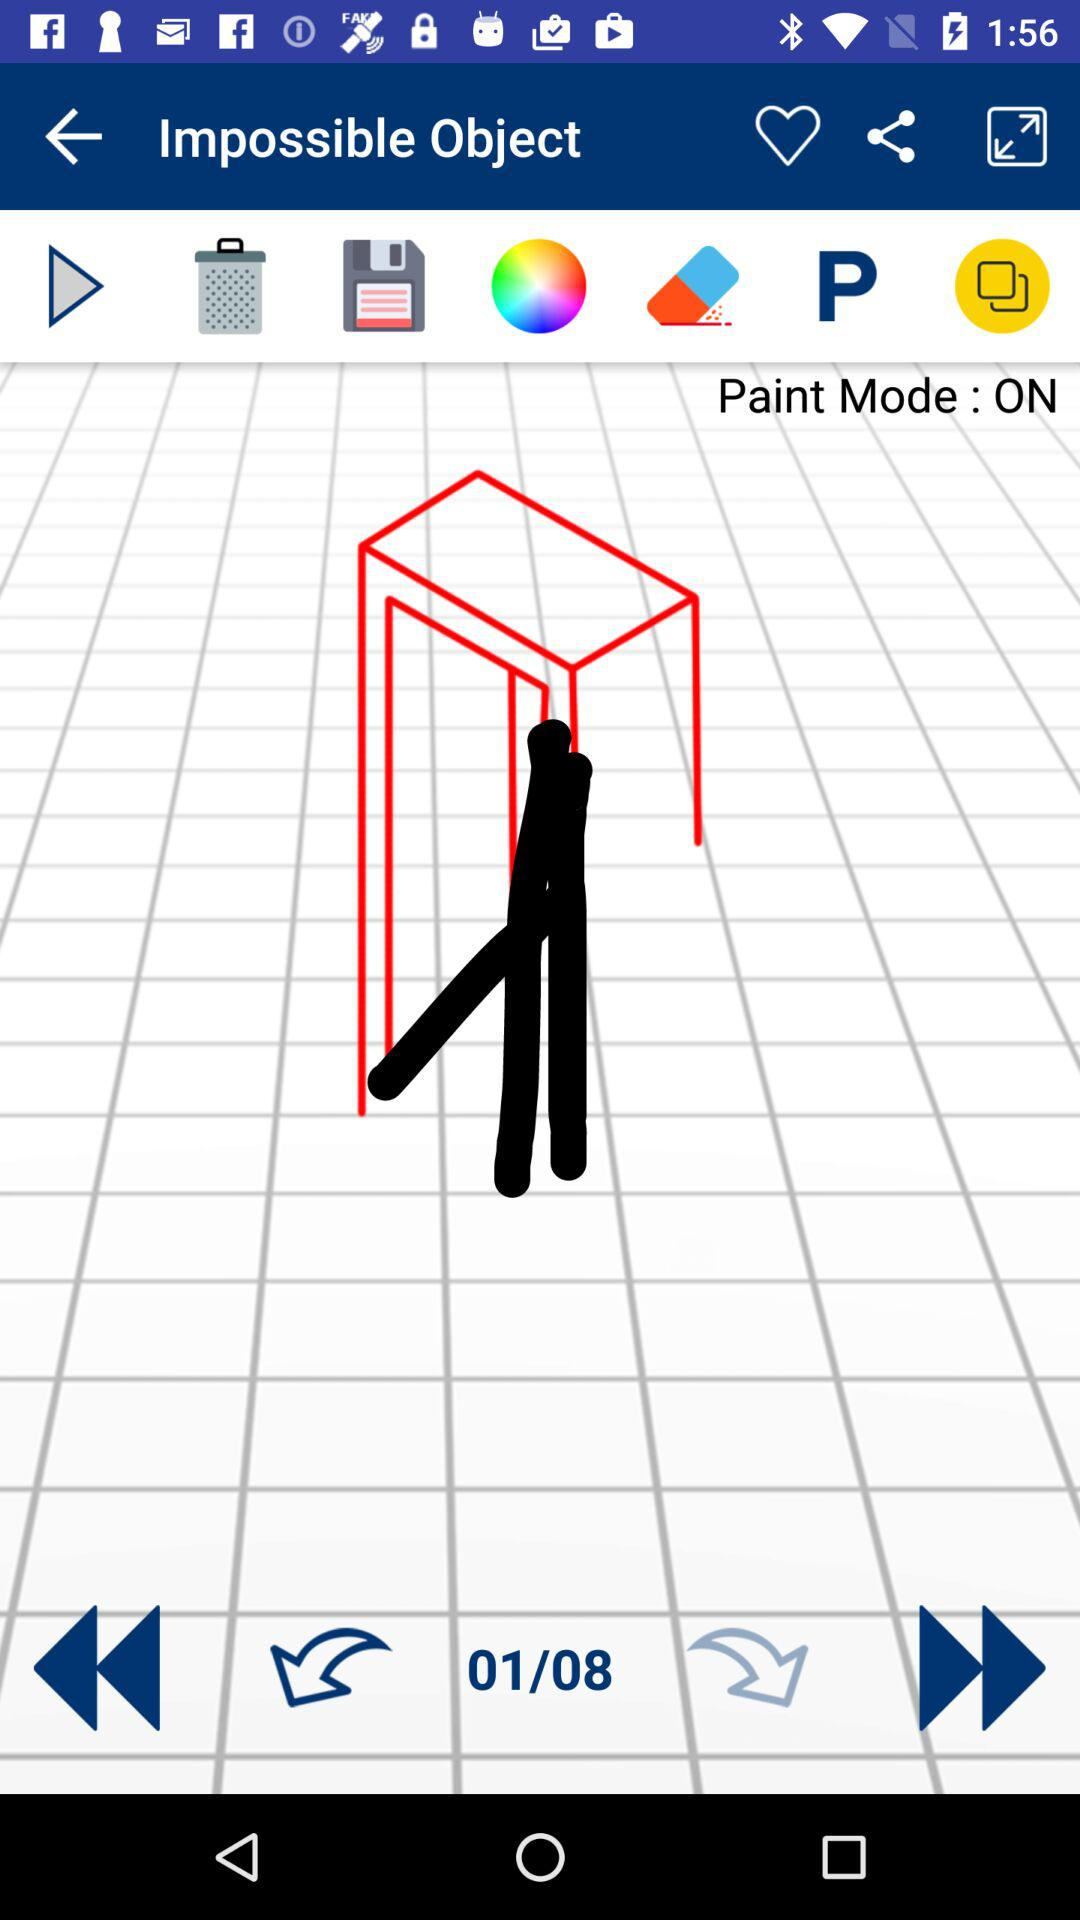What is the status of the "Paint Mode"? The status is "on". 